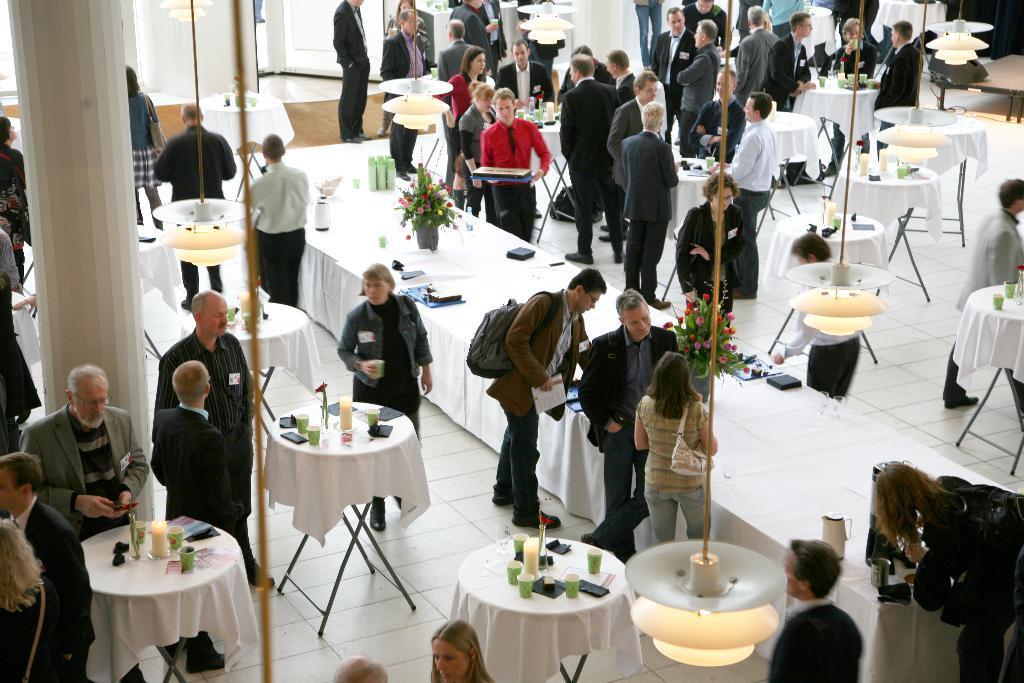Describe this image in one or two sentences. This is a picture taken in a room, there are a group of people standing on the floor in front of these people there is a tables on the tables there are mobiles, glasses, bottle and a flower pot. behind the people there is a pillar and a wall. 